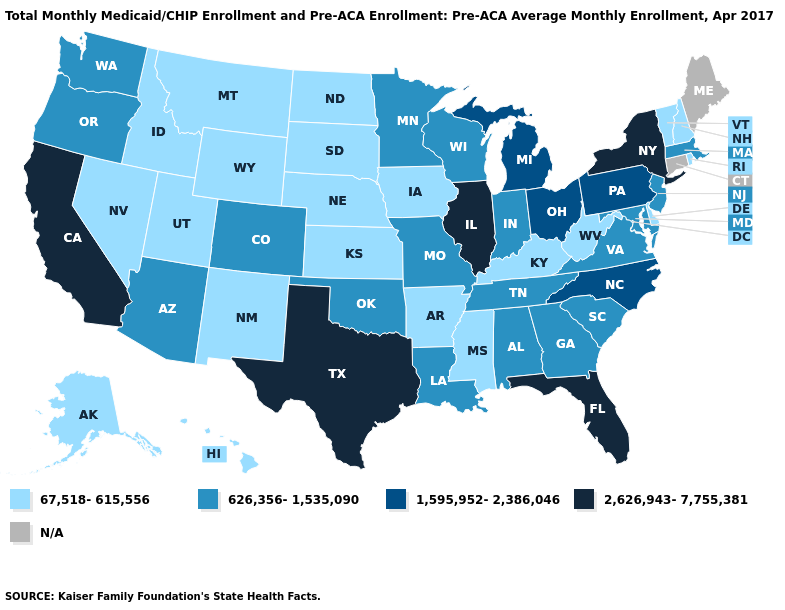What is the value of Nebraska?
Give a very brief answer. 67,518-615,556. Name the states that have a value in the range 2,626,943-7,755,381?
Be succinct. California, Florida, Illinois, New York, Texas. What is the highest value in the USA?
Give a very brief answer. 2,626,943-7,755,381. Does the map have missing data?
Concise answer only. Yes. What is the value of Ohio?
Concise answer only. 1,595,952-2,386,046. Name the states that have a value in the range 626,356-1,535,090?
Write a very short answer. Alabama, Arizona, Colorado, Georgia, Indiana, Louisiana, Maryland, Massachusetts, Minnesota, Missouri, New Jersey, Oklahoma, Oregon, South Carolina, Tennessee, Virginia, Washington, Wisconsin. Among the states that border Vermont , does New Hampshire have the lowest value?
Give a very brief answer. Yes. Name the states that have a value in the range 626,356-1,535,090?
Concise answer only. Alabama, Arizona, Colorado, Georgia, Indiana, Louisiana, Maryland, Massachusetts, Minnesota, Missouri, New Jersey, Oklahoma, Oregon, South Carolina, Tennessee, Virginia, Washington, Wisconsin. Name the states that have a value in the range 2,626,943-7,755,381?
Give a very brief answer. California, Florida, Illinois, New York, Texas. Among the states that border Oklahoma , does Arkansas have the highest value?
Keep it brief. No. What is the value of Tennessee?
Quick response, please. 626,356-1,535,090. 